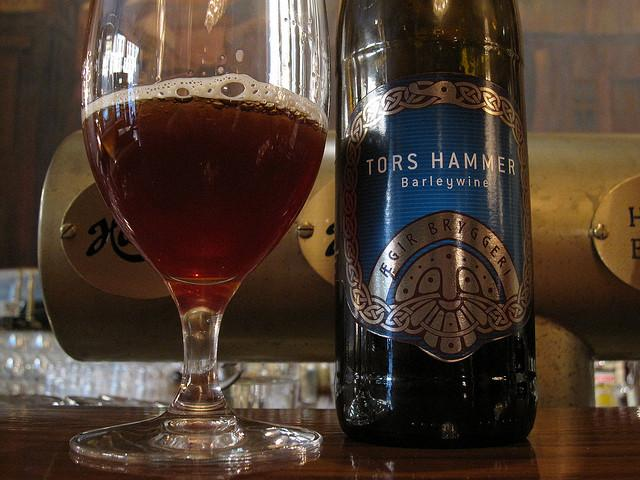The bottle is related to what group of people?

Choices:
A) pharaohs
B) samurai
C) roman legionnaires
D) vikings vikings 